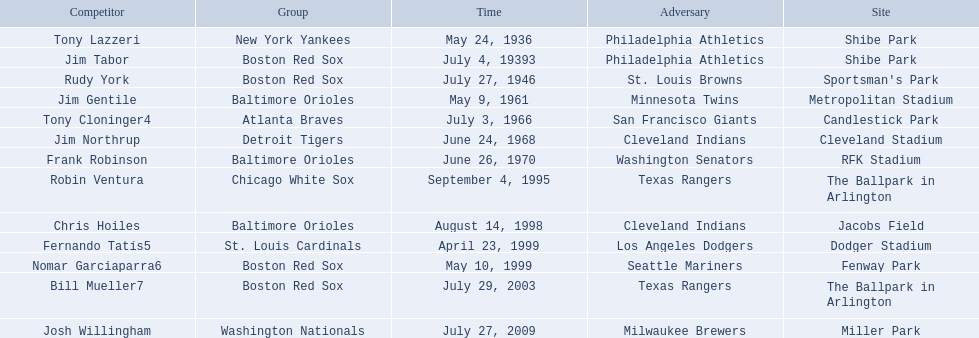Who were all the teams? New York Yankees, Boston Red Sox, Boston Red Sox, Baltimore Orioles, Atlanta Braves, Detroit Tigers, Baltimore Orioles, Chicago White Sox, Baltimore Orioles, St. Louis Cardinals, Boston Red Sox, Boston Red Sox, Washington Nationals. What about opponents? Philadelphia Athletics, Philadelphia Athletics, St. Louis Browns, Minnesota Twins, San Francisco Giants, Cleveland Indians, Washington Senators, Texas Rangers, Cleveland Indians, Los Angeles Dodgers, Seattle Mariners, Texas Rangers, Milwaukee Brewers. And when did they play? May 24, 1936, July 4, 19393, July 27, 1946, May 9, 1961, July 3, 1966, June 24, 1968, June 26, 1970, September 4, 1995, August 14, 1998, April 23, 1999, May 10, 1999, July 29, 2003, July 27, 2009. Which team played the red sox on july 27, 1946	? St. Louis Browns. 